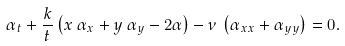Convert formula to latex. <formula><loc_0><loc_0><loc_500><loc_500>\alpha _ { t } + \frac { k } { t } \left ( x \, \alpha _ { x } + y \, \alpha _ { y } - 2 \alpha \right ) - \nu \, \left ( \alpha _ { x x } + \alpha _ { y y } \right ) = 0 .</formula> 